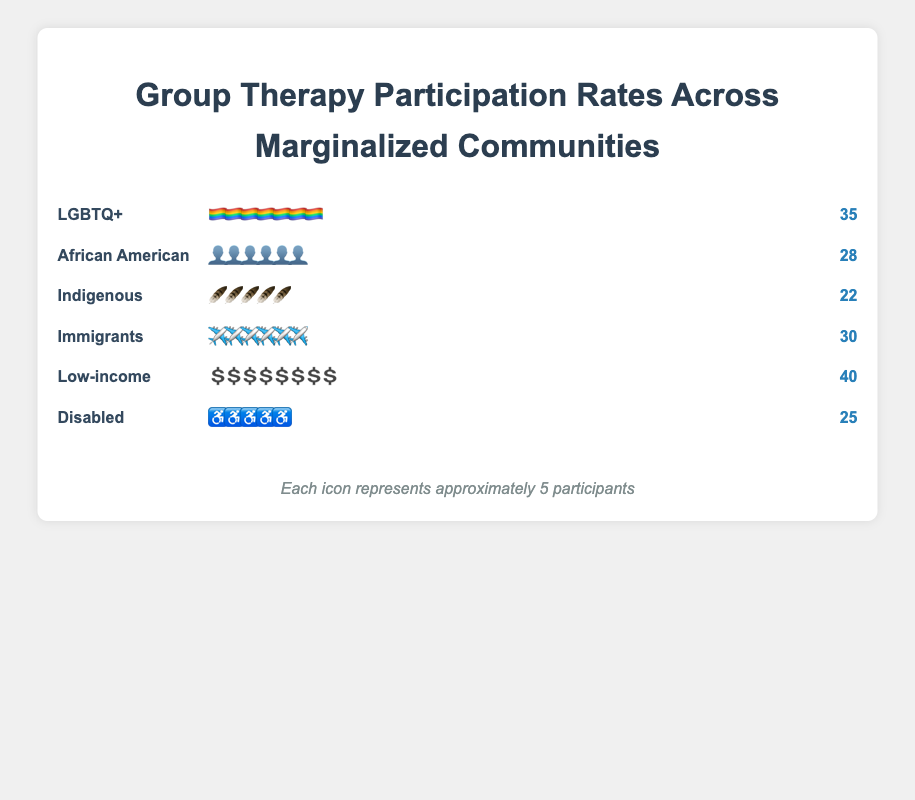What community has the highest participation in group therapy sessions? By scanning the figure, we identify the community with the most participants. The "Low-income" community has the highest number of participants with a total of 40 people.
Answer: Low-income Which icon represents the LGBTQ+ community in the chart? The icon representing the LGBTQ+ community is shown as a rainbow flag (🏳️‍🌈), as indicated in the figure.
Answer: Rainbow flag How many participants are there in the Indigenous community? The figure shows the Indigenous community participants with feather icons (🪶), and each feather represents a certain number of participants. Counting these feathers reveals that there are 22 participants.
Answer: 22 Compare the participation rates of the African American and Disabled communities. Which has more participants? By comparing the charts for both communities, we see that the African American community has 28 participants while the Disabled community has 25 participants. Hence, the African American community has more participants.
Answer: African American What is the total number of participants across all communities? We need to sum the participants of each community: LGBTQ+ (35) + African American (28) + Indigenous (22) + Immigrants (30) + Low-income (40) + Disabled (25). This totals to 180 participants.
Answer: 180 Which communities have fewer than 30 participants? Looking at the figure, we find that the African American (28), Indigenous (22), and Disabled (25) communities each have fewer than 30 participants.
Answer: African American, Indigenous, Disabled How many more participants does the Low-income community have compared to the Indigenous community? The Low-income community has 40 participants, while the Indigenous community has 22. The difference is calculated as 40 - 22 = 18 more participants.
Answer: 18 What's the average number of participants per community? Adding up all participants (180) and dividing by the number of communities (6) gives the average: 180 / 6 = 30 participants per community.
Answer: 30 For the LGBTQ+ community, how many icons are used to represent the participants if each icon represents approximately 5 participants? The LGBTQ+ community has 35 participants. Since each icon represents approximately 5 participants, 35 / 5 = 7 icons are used.
Answer: 7 Identify the community represented by the airplane icon and state its number of participants. The airplane icon corresponds to the Immigrants community. The number of participants in this community is 30.
Answer: Immigrants, 30 